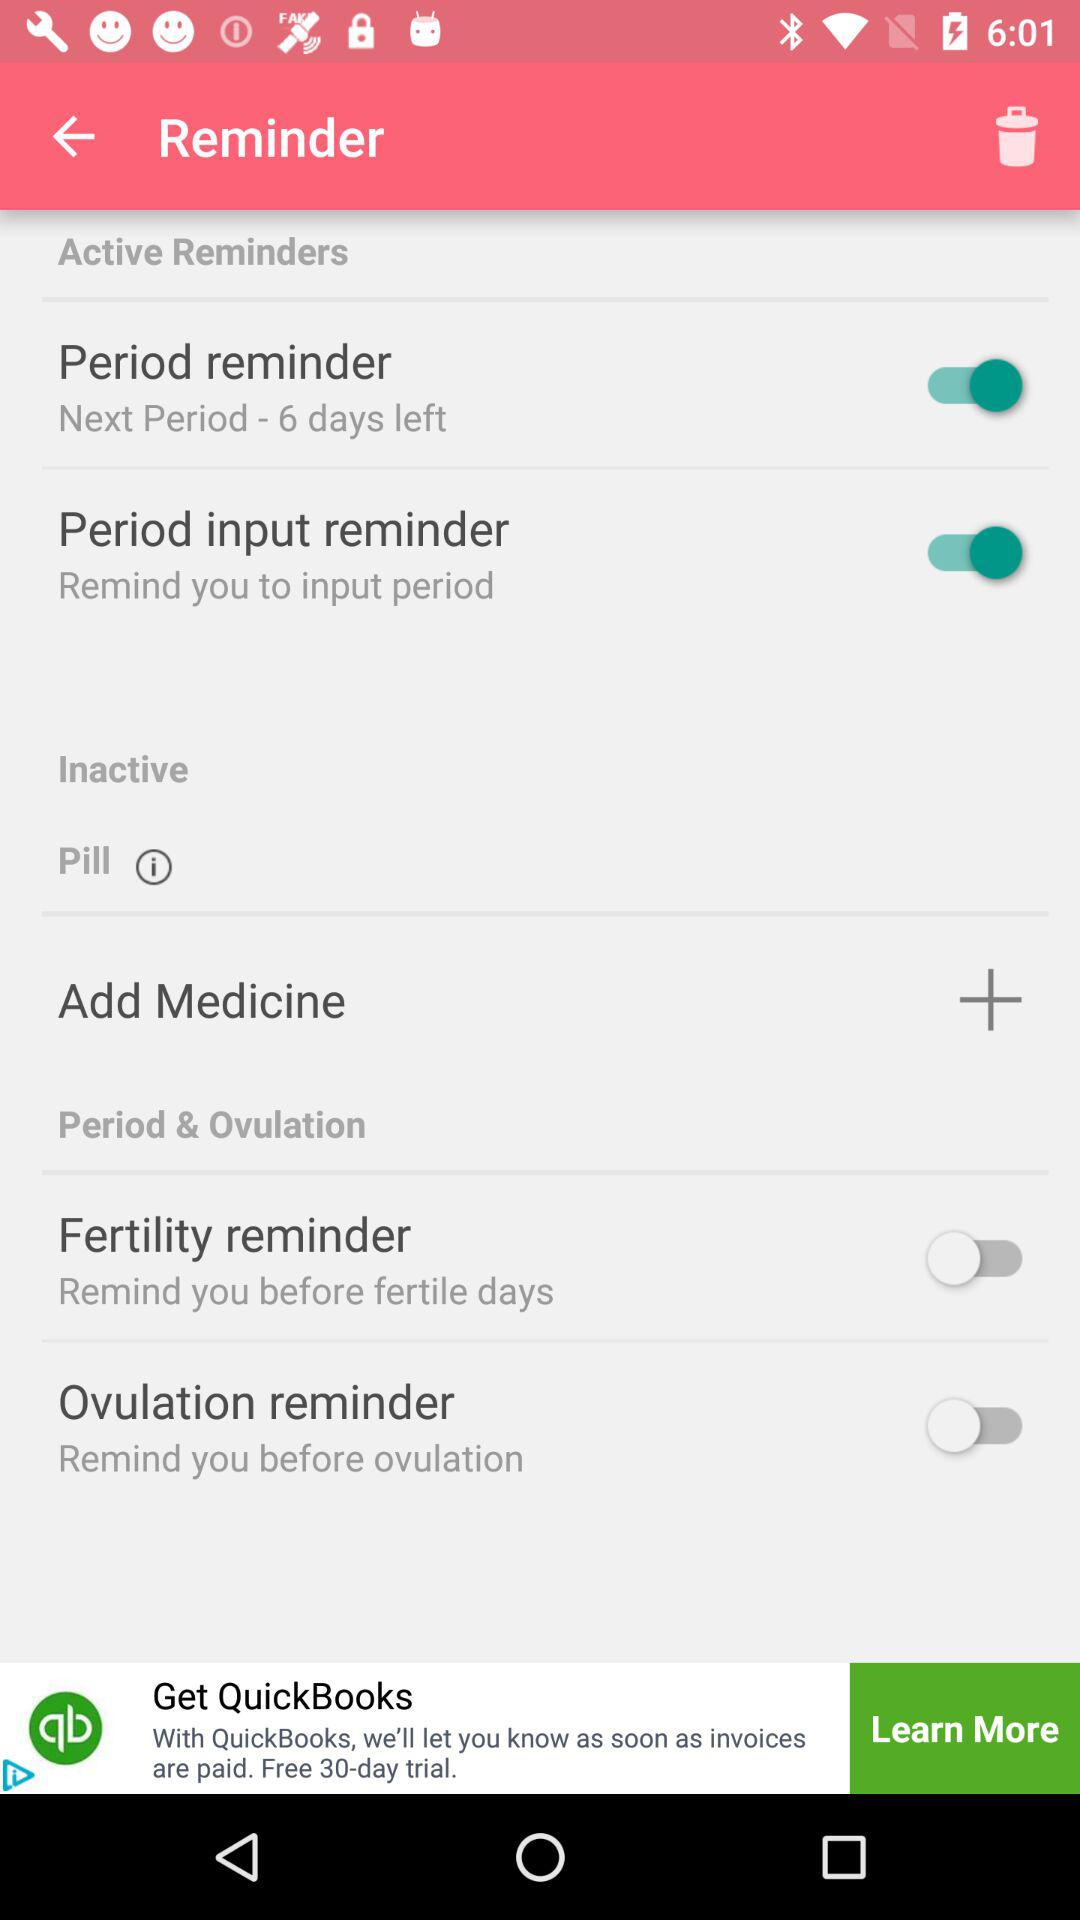How many reminders are about periods?
Answer the question using a single word or phrase. 2 